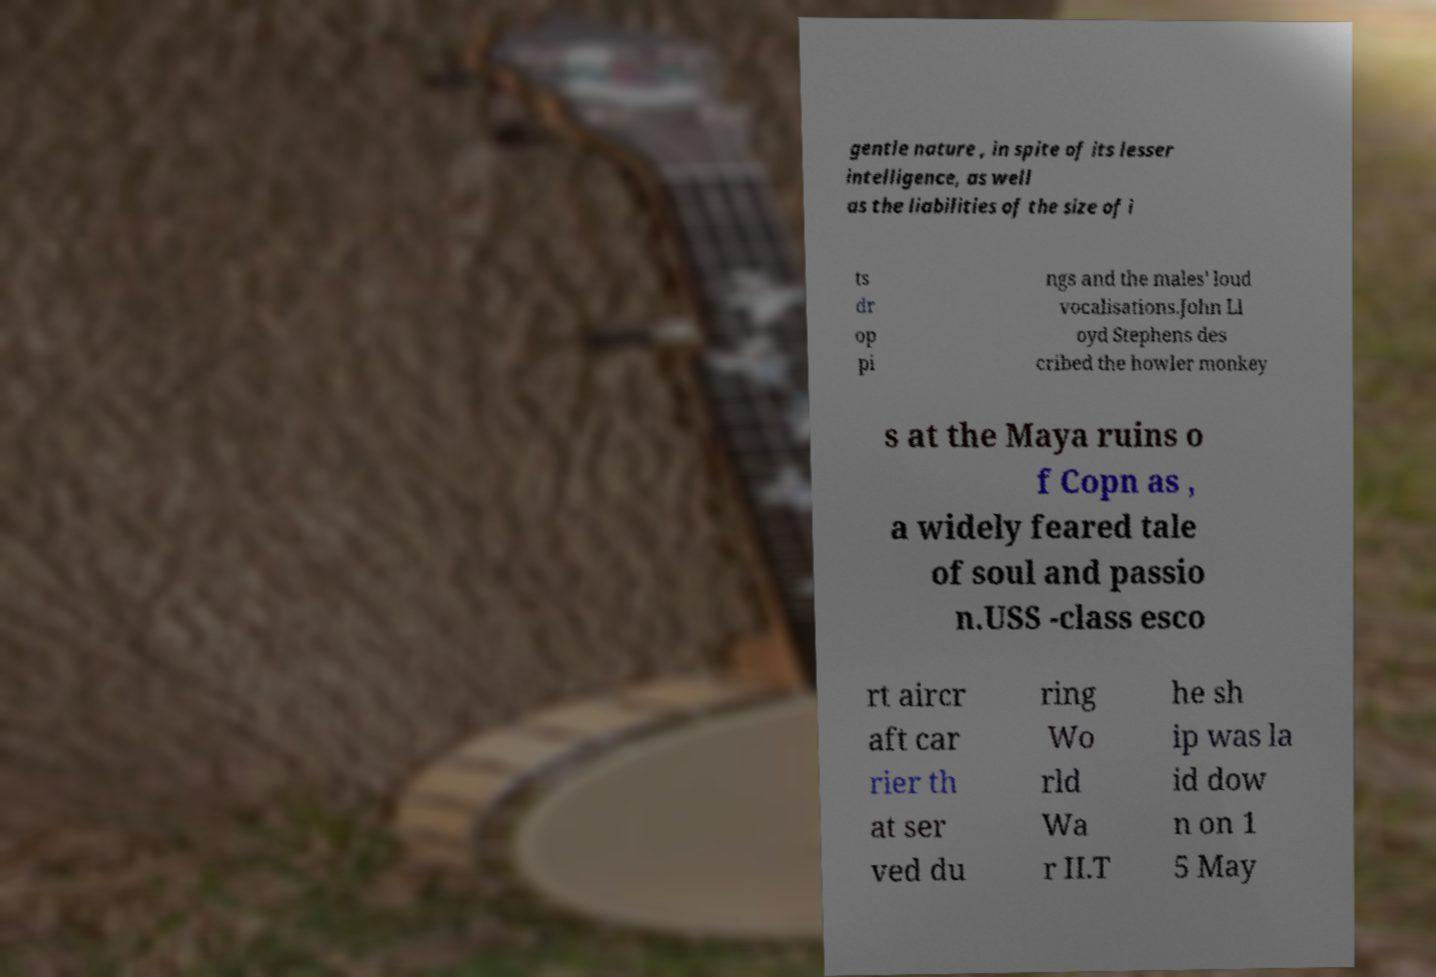For documentation purposes, I need the text within this image transcribed. Could you provide that? gentle nature , in spite of its lesser intelligence, as well as the liabilities of the size of i ts dr op pi ngs and the males' loud vocalisations.John Ll oyd Stephens des cribed the howler monkey s at the Maya ruins o f Copn as , a widely feared tale of soul and passio n.USS -class esco rt aircr aft car rier th at ser ved du ring Wo rld Wa r II.T he sh ip was la id dow n on 1 5 May 